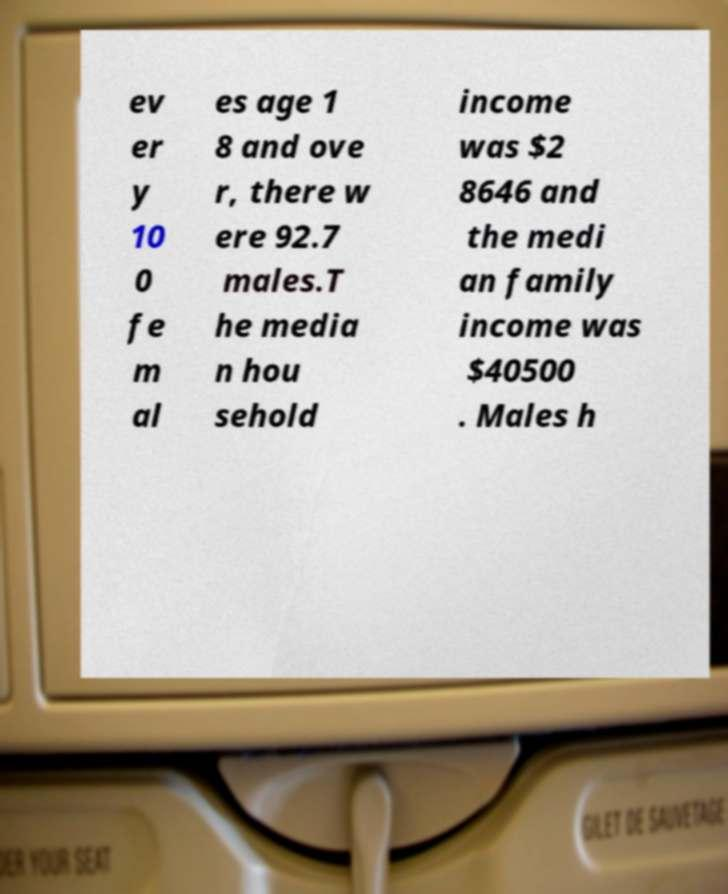Could you assist in decoding the text presented in this image and type it out clearly? ev er y 10 0 fe m al es age 1 8 and ove r, there w ere 92.7 males.T he media n hou sehold income was $2 8646 and the medi an family income was $40500 . Males h 